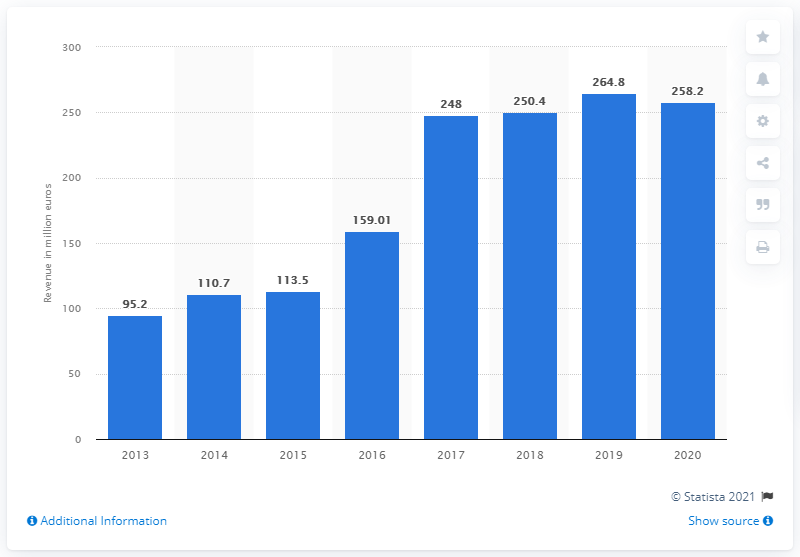Point out several critical features in this image. The revenue generated from Angry Birds' games segment was 258.2 million. The data from 2013, which was 95.2, doubled or more in the following years, namely 2017. The last year represented in the chart is 2020. 